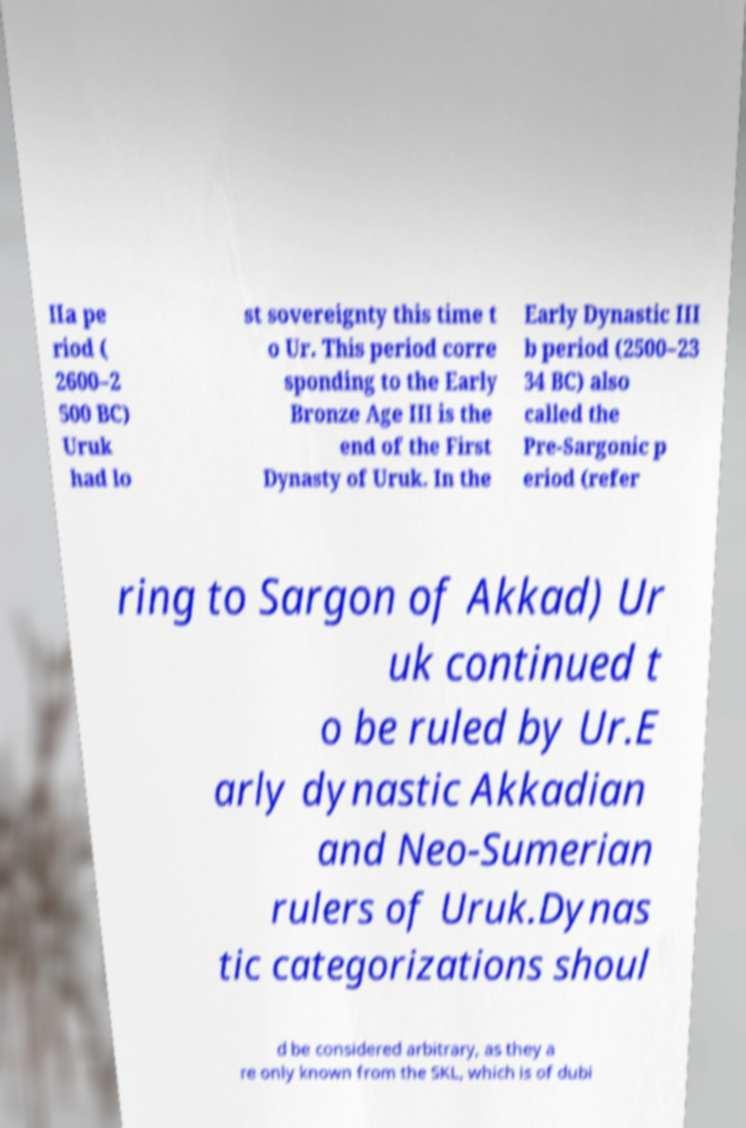Please identify and transcribe the text found in this image. IIa pe riod ( 2600–2 500 BC) Uruk had lo st sovereignty this time t o Ur. This period corre sponding to the Early Bronze Age III is the end of the First Dynasty of Uruk. In the Early Dynastic III b period (2500–23 34 BC) also called the Pre-Sargonic p eriod (refer ring to Sargon of Akkad) Ur uk continued t o be ruled by Ur.E arly dynastic Akkadian and Neo-Sumerian rulers of Uruk.Dynas tic categorizations shoul d be considered arbitrary, as they a re only known from the SKL, which is of dubi 